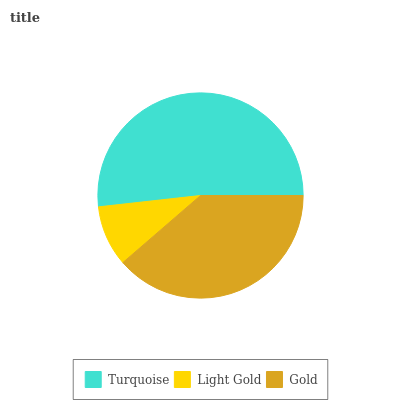Is Light Gold the minimum?
Answer yes or no. Yes. Is Turquoise the maximum?
Answer yes or no. Yes. Is Gold the minimum?
Answer yes or no. No. Is Gold the maximum?
Answer yes or no. No. Is Gold greater than Light Gold?
Answer yes or no. Yes. Is Light Gold less than Gold?
Answer yes or no. Yes. Is Light Gold greater than Gold?
Answer yes or no. No. Is Gold less than Light Gold?
Answer yes or no. No. Is Gold the high median?
Answer yes or no. Yes. Is Gold the low median?
Answer yes or no. Yes. Is Light Gold the high median?
Answer yes or no. No. Is Light Gold the low median?
Answer yes or no. No. 